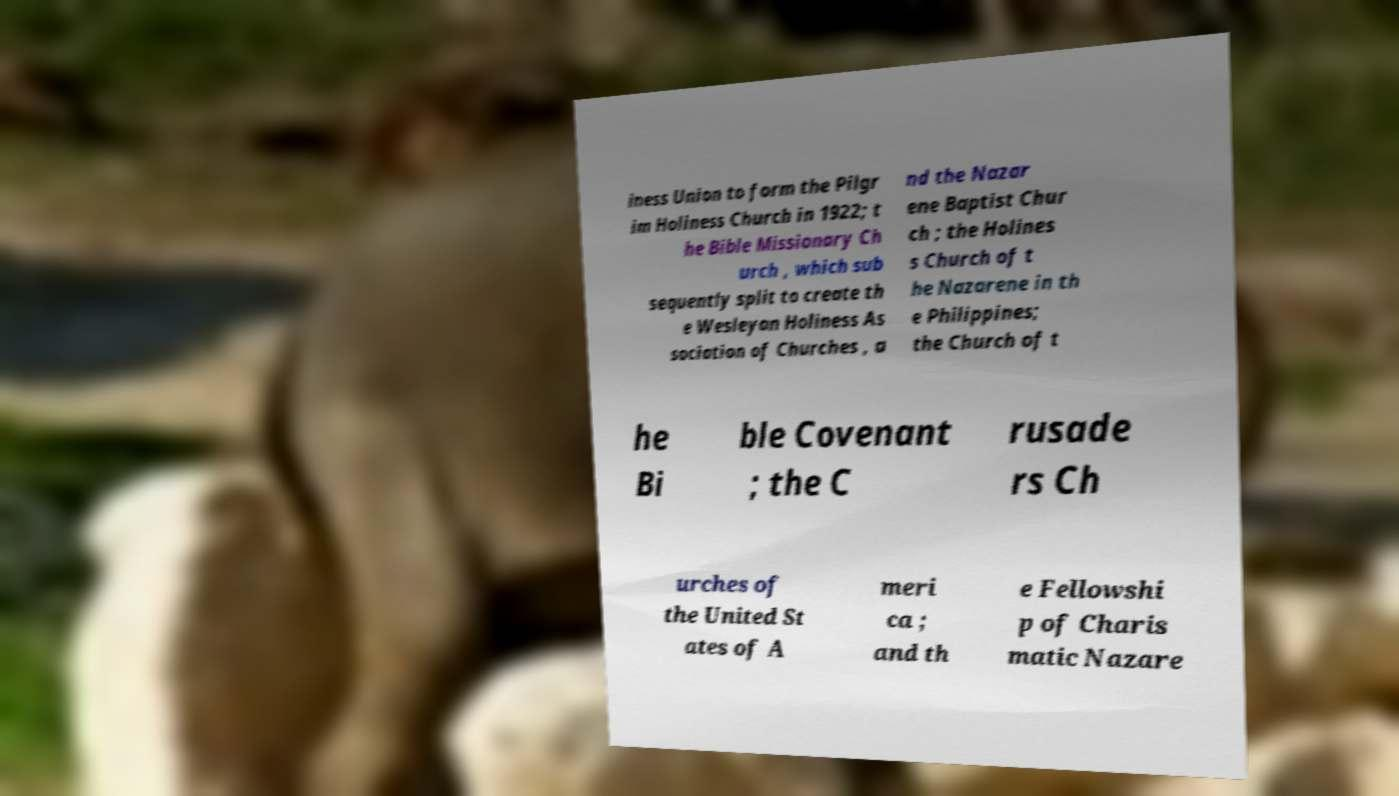I need the written content from this picture converted into text. Can you do that? iness Union to form the Pilgr im Holiness Church in 1922; t he Bible Missionary Ch urch , which sub sequently split to create th e Wesleyan Holiness As sociation of Churches , a nd the Nazar ene Baptist Chur ch ; the Holines s Church of t he Nazarene in th e Philippines; the Church of t he Bi ble Covenant ; the C rusade rs Ch urches of the United St ates of A meri ca ; and th e Fellowshi p of Charis matic Nazare 